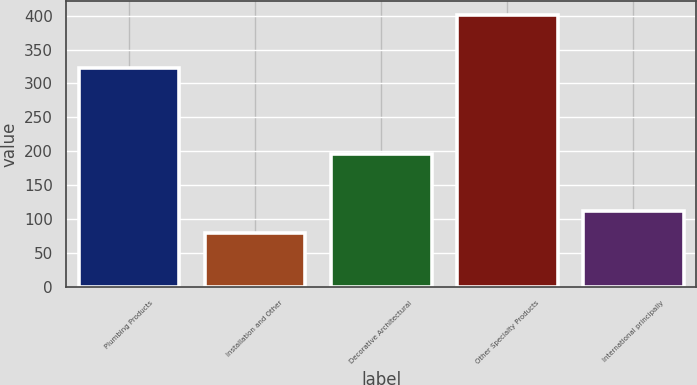Convert chart. <chart><loc_0><loc_0><loc_500><loc_500><bar_chart><fcel>Plumbing Products<fcel>Installation and Other<fcel>Decorative Architectural<fcel>Other Specialty Products<fcel>International principally<nl><fcel>322<fcel>79<fcel>196<fcel>401<fcel>111.2<nl></chart> 